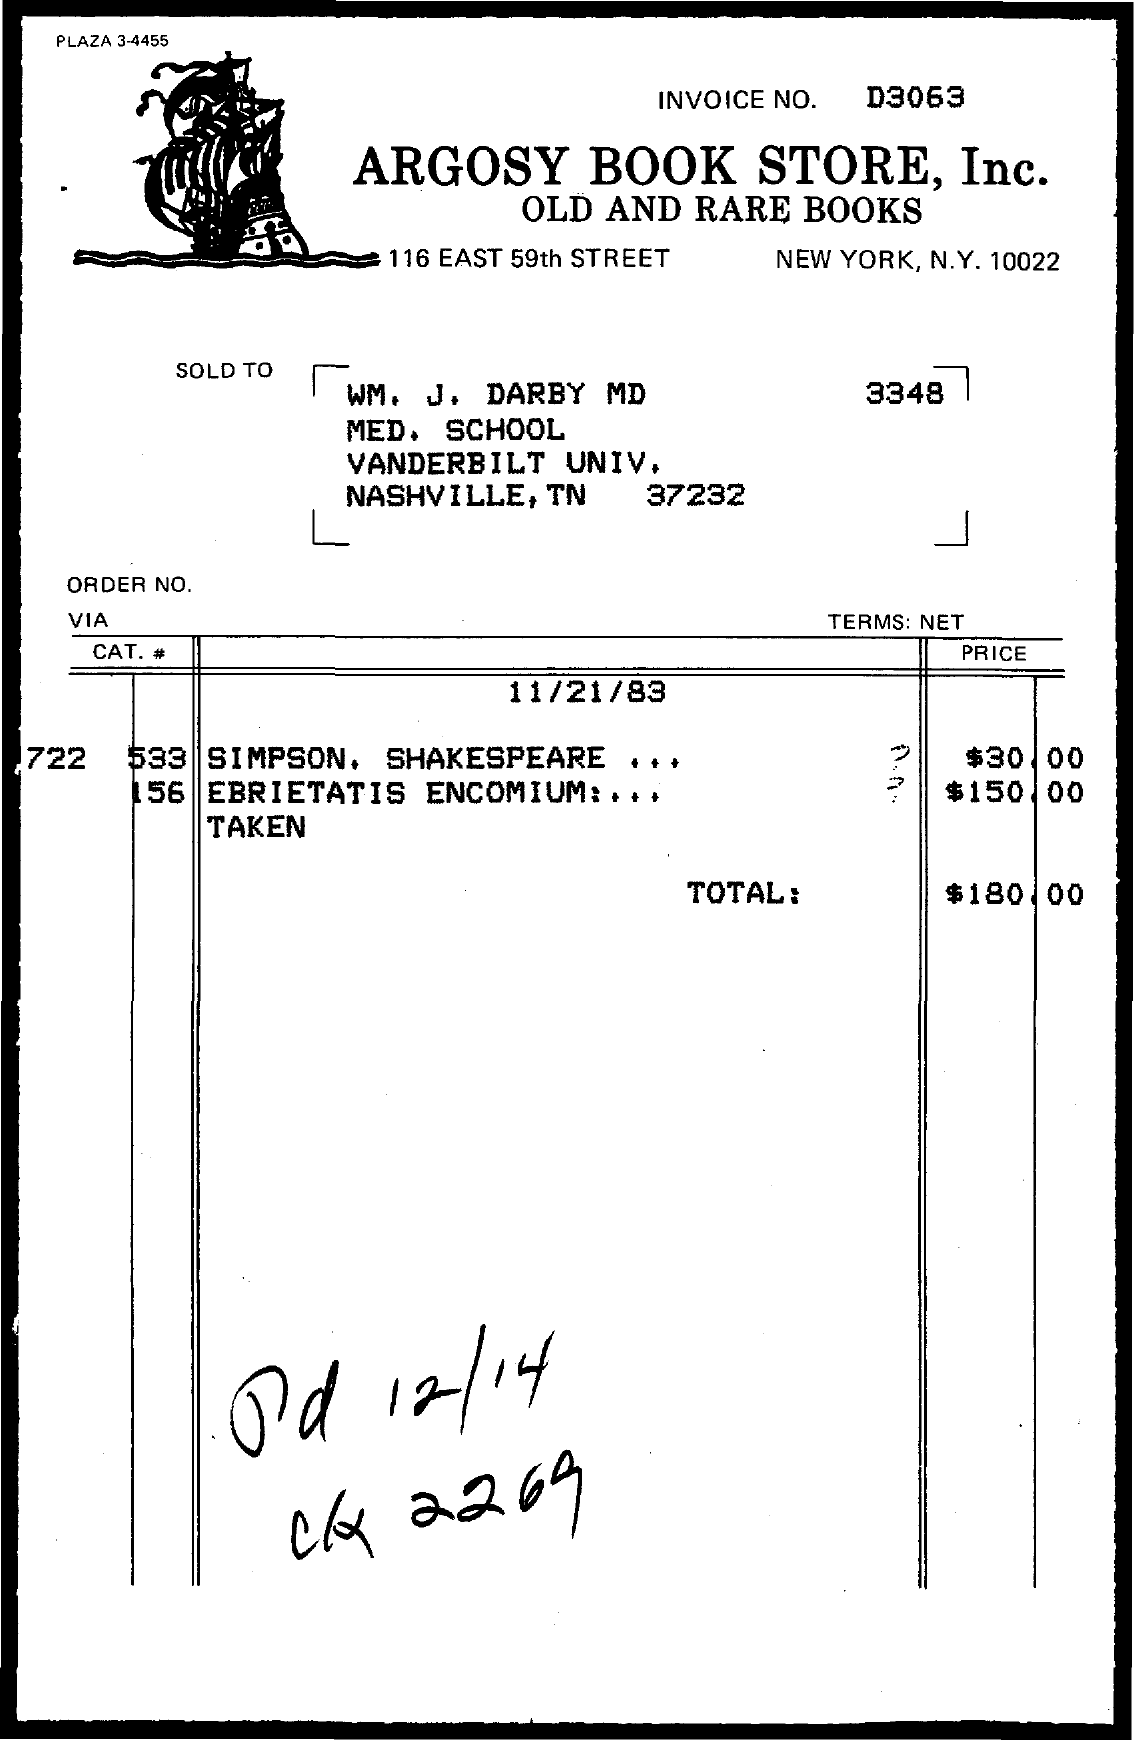What is the invoice number?
Ensure brevity in your answer.  D3063. Which book is the most expensive in the invoice?
Ensure brevity in your answer.  EBRIETATIS ENCOMIUM. What is the total value in the invoice?
Make the answer very short. $180.00. 